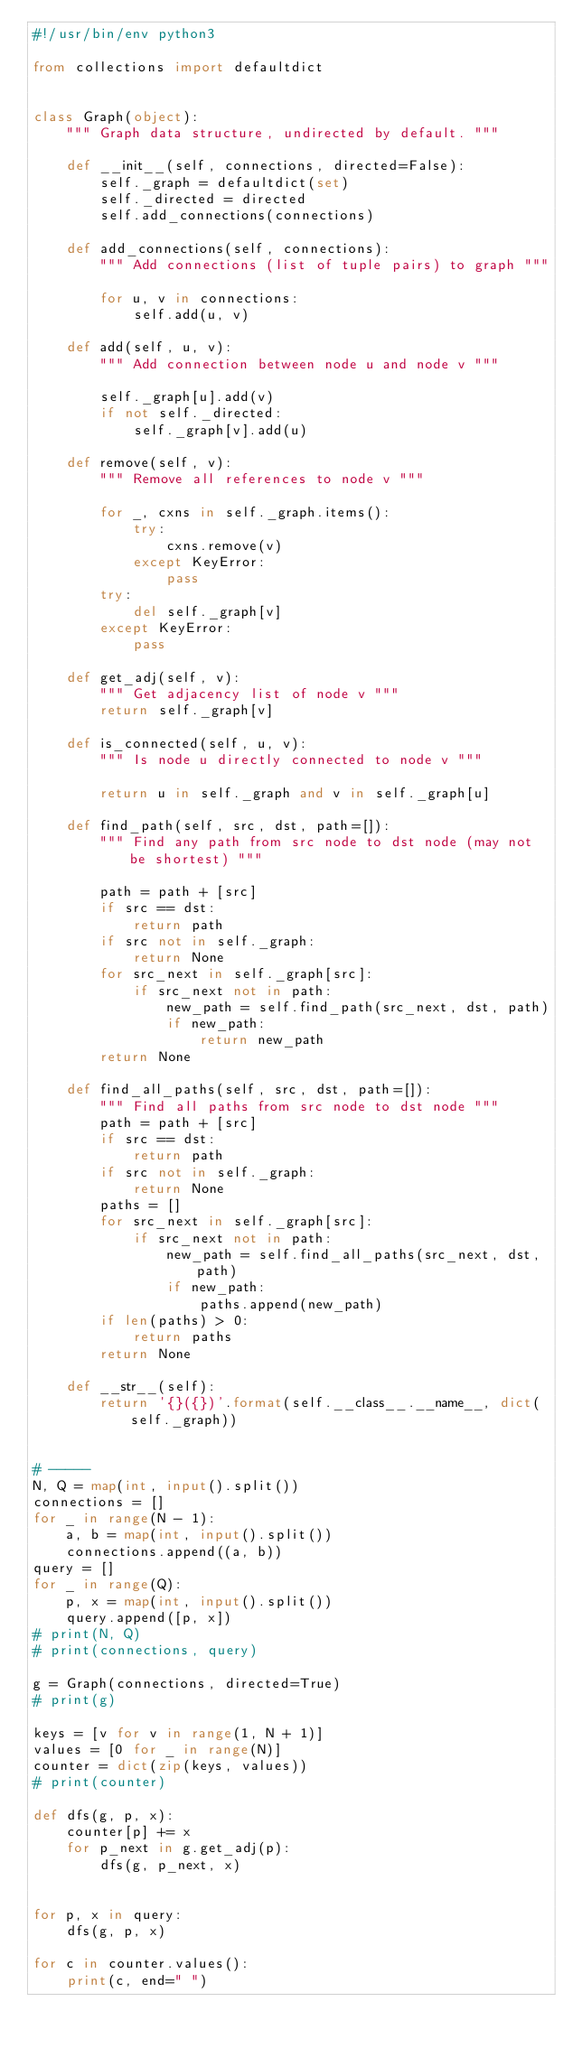Convert code to text. <code><loc_0><loc_0><loc_500><loc_500><_Python_>#!/usr/bin/env python3

from collections import defaultdict


class Graph(object):
    """ Graph data structure, undirected by default. """

    def __init__(self, connections, directed=False):
        self._graph = defaultdict(set)
        self._directed = directed
        self.add_connections(connections)

    def add_connections(self, connections):
        """ Add connections (list of tuple pairs) to graph """

        for u, v in connections:
            self.add(u, v)

    def add(self, u, v):
        """ Add connection between node u and node v """

        self._graph[u].add(v)
        if not self._directed:
            self._graph[v].add(u)

    def remove(self, v):
        """ Remove all references to node v """

        for _, cxns in self._graph.items():
            try:
                cxns.remove(v)
            except KeyError:
                pass
        try:
            del self._graph[v]
        except KeyError:
            pass

    def get_adj(self, v):
        """ Get adjacency list of node v """
        return self._graph[v]

    def is_connected(self, u, v):
        """ Is node u directly connected to node v """

        return u in self._graph and v in self._graph[u]

    def find_path(self, src, dst, path=[]):
        """ Find any path from src node to dst node (may not be shortest) """

        path = path + [src]
        if src == dst:
            return path
        if src not in self._graph:
            return None
        for src_next in self._graph[src]:
            if src_next not in path:
                new_path = self.find_path(src_next, dst, path)
                if new_path:
                    return new_path
        return None

    def find_all_paths(self, src, dst, path=[]):
        """ Find all paths from src node to dst node """
        path = path + [src]
        if src == dst:
            return path
        if src not in self._graph:
            return None
        paths = []
        for src_next in self._graph[src]:
            if src_next not in path:
                new_path = self.find_all_paths(src_next, dst, path)
                if new_path:
                    paths.append(new_path)
        if len(paths) > 0:
            return paths
        return None

    def __str__(self):
        return '{}({})'.format(self.__class__.__name__, dict(self._graph))


# -----
N, Q = map(int, input().split())
connections = []
for _ in range(N - 1):
    a, b = map(int, input().split())
    connections.append((a, b))
query = []
for _ in range(Q):
    p, x = map(int, input().split())
    query.append([p, x])
# print(N, Q)
# print(connections, query)

g = Graph(connections, directed=True)
# print(g)

keys = [v for v in range(1, N + 1)]
values = [0 for _ in range(N)]
counter = dict(zip(keys, values))
# print(counter)

def dfs(g, p, x):
    counter[p] += x
    for p_next in g.get_adj(p):
        dfs(g, p_next, x)


for p, x in query:
    dfs(g, p, x)

for c in counter.values():
    print(c, end=" ")
</code> 